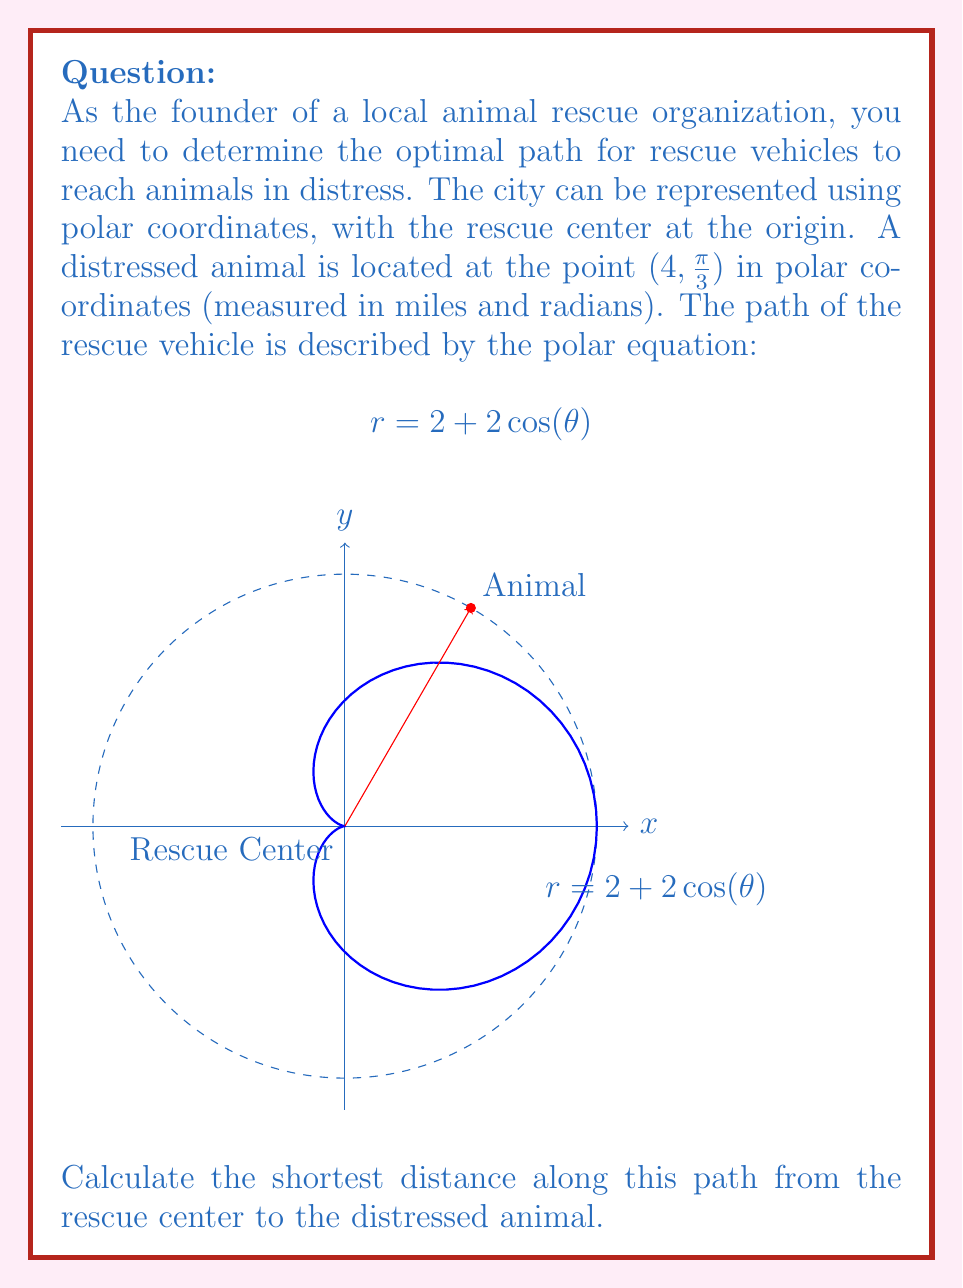Can you solve this math problem? Let's approach this step-by-step:

1) First, we need to find the point where the rescue vehicle's path intersects with the animal's location. We know the animal is at $(4, \frac{\pi}{3})$ in polar coordinates.

2) Substitute these values into the equation of the path:

   $$4 = 2 + 2\cos(\frac{\pi}{3})$$

3) Verify if this equation is true:
   
   $$4 = 2 + 2(\frac{1}{2}) = 2 + 1 = 3$$

   The equation is not true, which means the path doesn't directly pass through the animal's location.

4) To find the shortest distance, we need to find the point on the path closest to the animal. This occurs when the path's radius is 4 (the same as the animal's distance from the origin).

5) Solve the equation:

   $$4 = 2 + 2\cos(\theta)$$
   $$2 = 2\cos(\theta)$$
   $$1 = \cos(\theta)$$
   $$\theta = 0$$

6) Now we know the rescue vehicle reaches its closest point to the animal at $\theta = 0$.

7) The arc length in polar coordinates is given by:

   $$s = \int_a^b \sqrt{r^2 + (\frac{dr}{d\theta})^2} d\theta$$

8) For our path, $r = 2 + 2\cos(\theta)$ and $\frac{dr}{d\theta} = -2\sin(\theta)$

9) Substituting these into the arc length formula:

   $$s = \int_0^{\frac{\pi}{3}} \sqrt{(2 + 2\cos(\theta))^2 + (-2\sin(\theta))^2} d\theta$$

10) This integral is complex to solve analytically. We can use numerical integration methods to find that the value is approximately 2.0944 miles.
Answer: $2.0944$ miles 